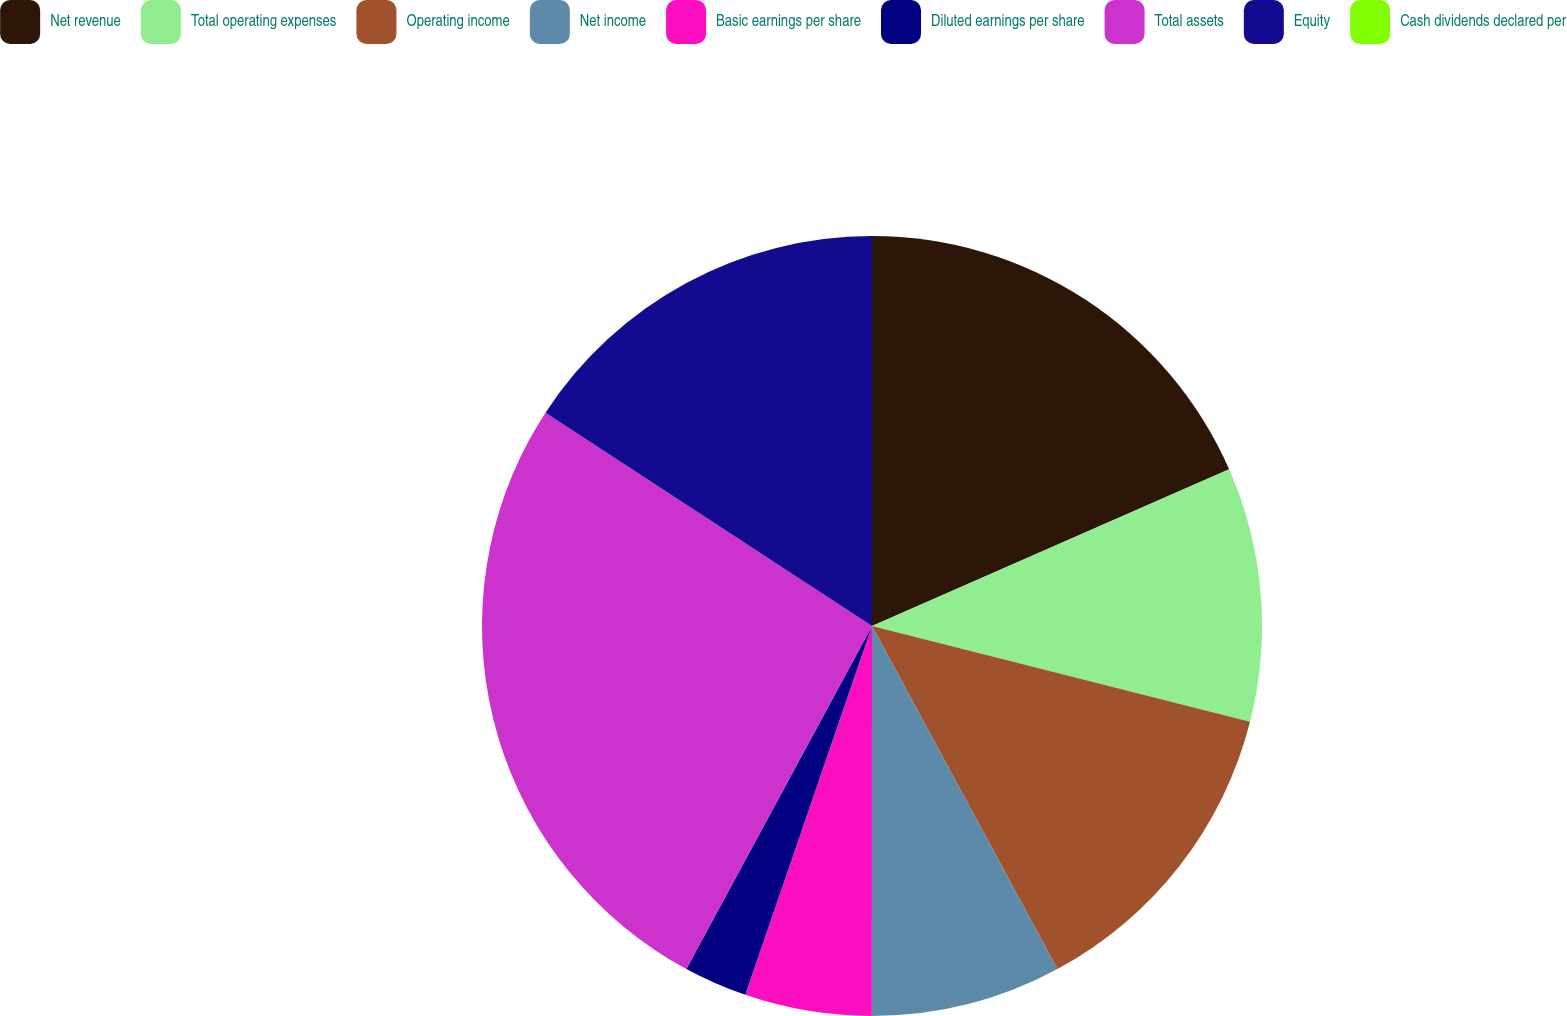<chart> <loc_0><loc_0><loc_500><loc_500><pie_chart><fcel>Net revenue<fcel>Total operating expenses<fcel>Operating income<fcel>Net income<fcel>Basic earnings per share<fcel>Diluted earnings per share<fcel>Total assets<fcel>Equity<fcel>Cash dividends declared per<nl><fcel>18.42%<fcel>10.53%<fcel>13.16%<fcel>7.89%<fcel>5.26%<fcel>2.63%<fcel>26.31%<fcel>15.79%<fcel>0.0%<nl></chart> 